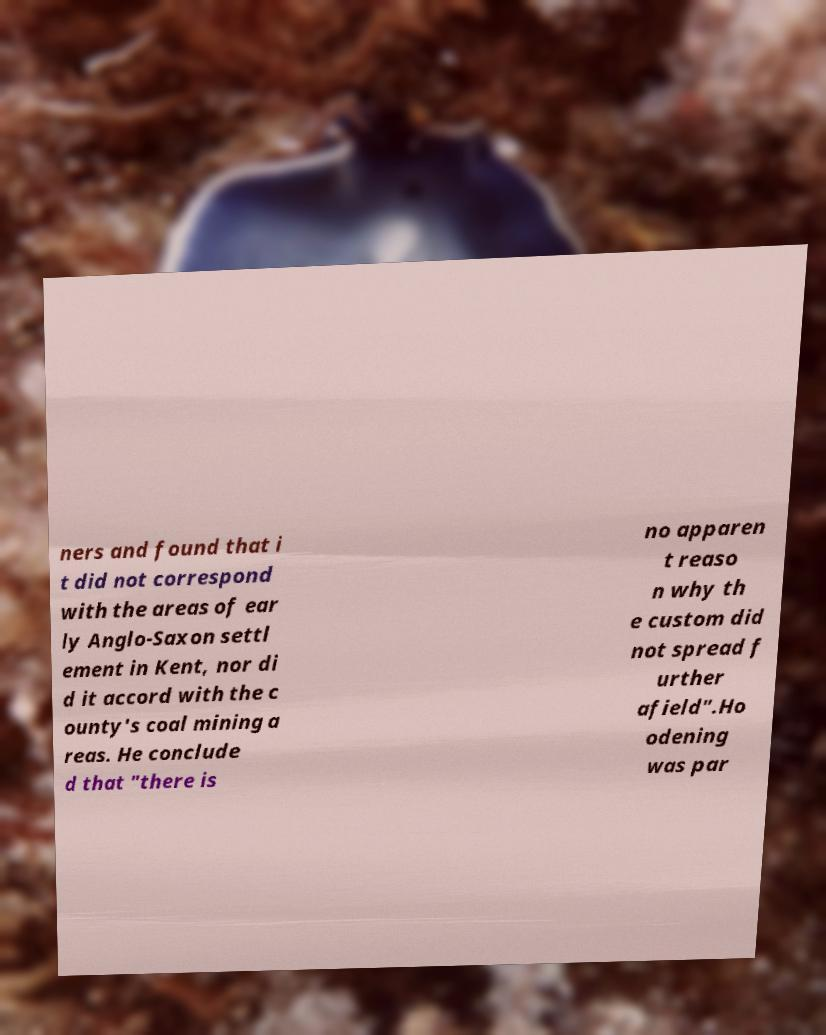I need the written content from this picture converted into text. Can you do that? ners and found that i t did not correspond with the areas of ear ly Anglo-Saxon settl ement in Kent, nor di d it accord with the c ounty's coal mining a reas. He conclude d that "there is no apparen t reaso n why th e custom did not spread f urther afield".Ho odening was par 